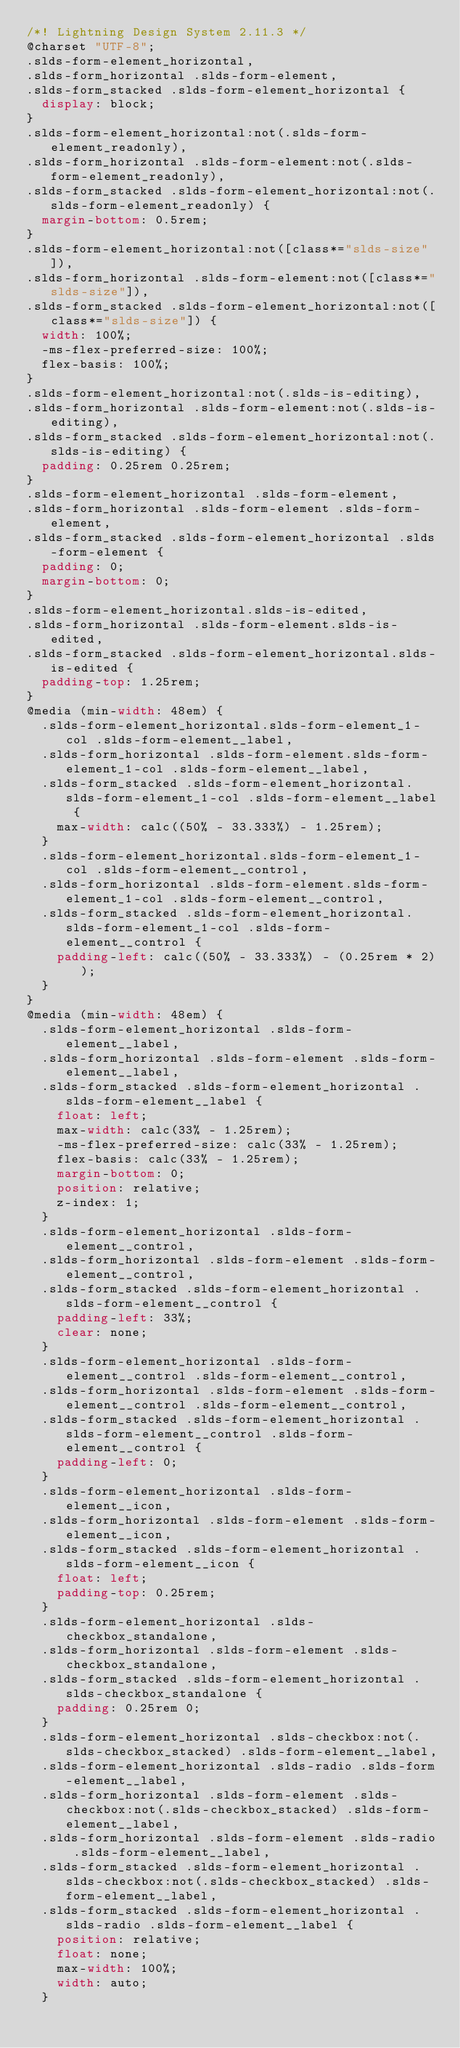Convert code to text. <code><loc_0><loc_0><loc_500><loc_500><_CSS_>/*! Lightning Design System 2.11.3 */
@charset "UTF-8";
.slds-form-element_horizontal,
.slds-form_horizontal .slds-form-element,
.slds-form_stacked .slds-form-element_horizontal {
  display: block;
}
.slds-form-element_horizontal:not(.slds-form-element_readonly),
.slds-form_horizontal .slds-form-element:not(.slds-form-element_readonly),
.slds-form_stacked .slds-form-element_horizontal:not(.slds-form-element_readonly) {
  margin-bottom: 0.5rem;
}
.slds-form-element_horizontal:not([class*="slds-size"]),
.slds-form_horizontal .slds-form-element:not([class*="slds-size"]),
.slds-form_stacked .slds-form-element_horizontal:not([class*="slds-size"]) {
  width: 100%;
  -ms-flex-preferred-size: 100%;
  flex-basis: 100%;
}
.slds-form-element_horizontal:not(.slds-is-editing),
.slds-form_horizontal .slds-form-element:not(.slds-is-editing),
.slds-form_stacked .slds-form-element_horizontal:not(.slds-is-editing) {
  padding: 0.25rem 0.25rem;
}
.slds-form-element_horizontal .slds-form-element,
.slds-form_horizontal .slds-form-element .slds-form-element,
.slds-form_stacked .slds-form-element_horizontal .slds-form-element {
  padding: 0;
  margin-bottom: 0;
}
.slds-form-element_horizontal.slds-is-edited,
.slds-form_horizontal .slds-form-element.slds-is-edited,
.slds-form_stacked .slds-form-element_horizontal.slds-is-edited {
  padding-top: 1.25rem;
}
@media (min-width: 48em) {
  .slds-form-element_horizontal.slds-form-element_1-col .slds-form-element__label,
  .slds-form_horizontal .slds-form-element.slds-form-element_1-col .slds-form-element__label,
  .slds-form_stacked .slds-form-element_horizontal.slds-form-element_1-col .slds-form-element__label {
    max-width: calc((50% - 33.333%) - 1.25rem);
  }
  .slds-form-element_horizontal.slds-form-element_1-col .slds-form-element__control,
  .slds-form_horizontal .slds-form-element.slds-form-element_1-col .slds-form-element__control,
  .slds-form_stacked .slds-form-element_horizontal.slds-form-element_1-col .slds-form-element__control {
    padding-left: calc((50% - 33.333%) - (0.25rem * 2));
  }
}
@media (min-width: 48em) {
  .slds-form-element_horizontal .slds-form-element__label,
  .slds-form_horizontal .slds-form-element .slds-form-element__label,
  .slds-form_stacked .slds-form-element_horizontal .slds-form-element__label {
    float: left;
    max-width: calc(33% - 1.25rem);
    -ms-flex-preferred-size: calc(33% - 1.25rem);
    flex-basis: calc(33% - 1.25rem);
    margin-bottom: 0;
    position: relative;
    z-index: 1;
  }
  .slds-form-element_horizontal .slds-form-element__control,
  .slds-form_horizontal .slds-form-element .slds-form-element__control,
  .slds-form_stacked .slds-form-element_horizontal .slds-form-element__control {
    padding-left: 33%;
    clear: none;
  }
  .slds-form-element_horizontal .slds-form-element__control .slds-form-element__control,
  .slds-form_horizontal .slds-form-element .slds-form-element__control .slds-form-element__control,
  .slds-form_stacked .slds-form-element_horizontal .slds-form-element__control .slds-form-element__control {
    padding-left: 0;
  }
  .slds-form-element_horizontal .slds-form-element__icon,
  .slds-form_horizontal .slds-form-element .slds-form-element__icon,
  .slds-form_stacked .slds-form-element_horizontal .slds-form-element__icon {
    float: left;
    padding-top: 0.25rem;
  }
  .slds-form-element_horizontal .slds-checkbox_standalone,
  .slds-form_horizontal .slds-form-element .slds-checkbox_standalone,
  .slds-form_stacked .slds-form-element_horizontal .slds-checkbox_standalone {
    padding: 0.25rem 0;
  }
  .slds-form-element_horizontal .slds-checkbox:not(.slds-checkbox_stacked) .slds-form-element__label,
  .slds-form-element_horizontal .slds-radio .slds-form-element__label,
  .slds-form_horizontal .slds-form-element .slds-checkbox:not(.slds-checkbox_stacked) .slds-form-element__label,
  .slds-form_horizontal .slds-form-element .slds-radio .slds-form-element__label,
  .slds-form_stacked .slds-form-element_horizontal .slds-checkbox:not(.slds-checkbox_stacked) .slds-form-element__label,
  .slds-form_stacked .slds-form-element_horizontal .slds-radio .slds-form-element__label {
    position: relative;
    float: none;
    max-width: 100%;
    width: auto;
  }</code> 